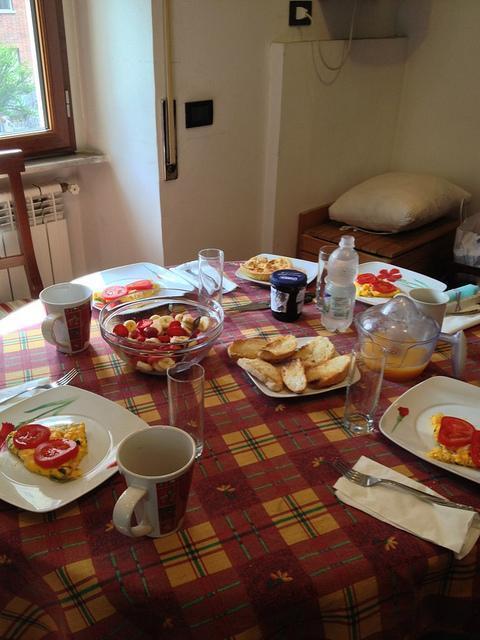What will they serve to drink?
Pick the correct solution from the four options below to address the question.
Options: Orange juice, milk, wine, grape juice. Orange juice. 